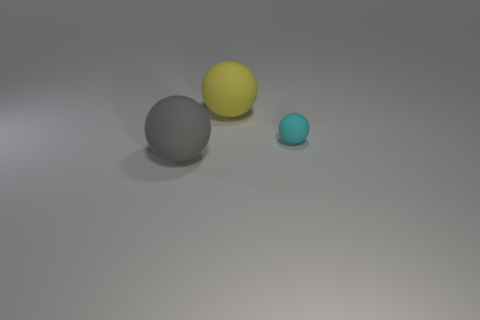Are there any other things that have the same size as the cyan matte object?
Make the answer very short. No. There is a small cyan matte thing; what shape is it?
Offer a terse response. Sphere. The object that is in front of the yellow matte object and behind the gray object has what shape?
Your response must be concise. Sphere. There is a tiny thing that is made of the same material as the gray ball; what is its color?
Keep it short and to the point. Cyan. There is a matte thing on the left side of the big rubber sphere to the right of the big object that is in front of the small cyan sphere; what is its shape?
Your response must be concise. Sphere. The cyan rubber ball has what size?
Ensure brevity in your answer.  Small. What is the shape of the large gray thing that is the same material as the small cyan thing?
Provide a short and direct response. Sphere. Are there fewer yellow objects right of the big yellow rubber ball than tiny red metal things?
Make the answer very short. No. The thing right of the large yellow ball is what color?
Provide a succinct answer. Cyan. Are there any tiny rubber things that have the same shape as the large gray thing?
Give a very brief answer. Yes. 